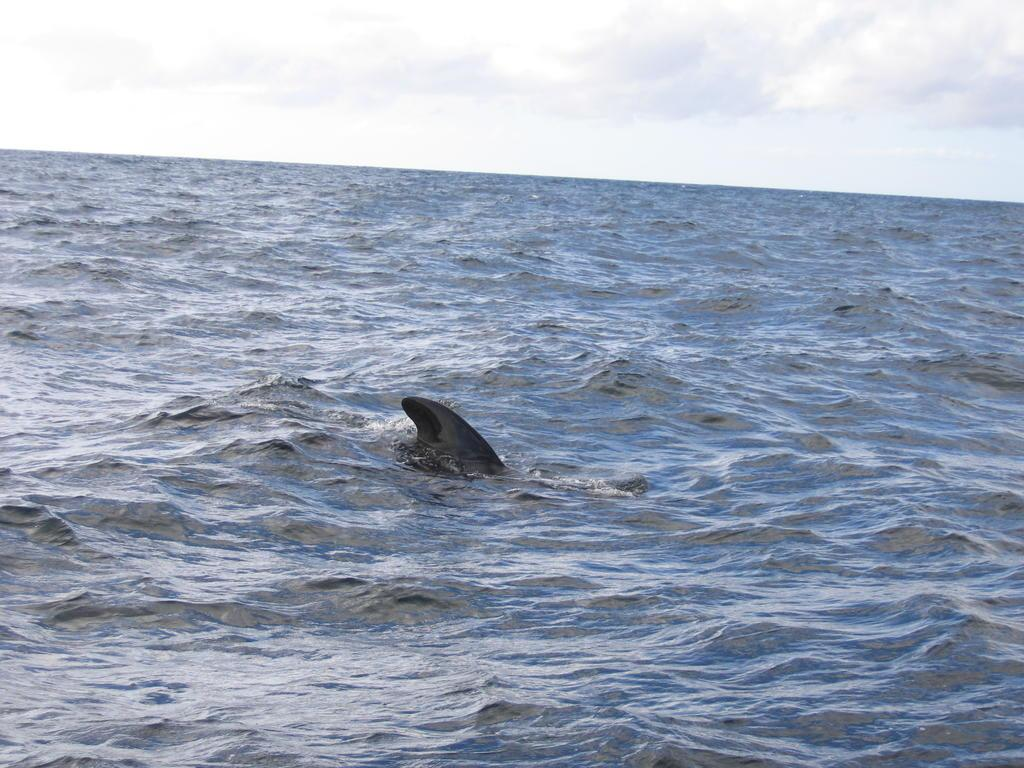What is the primary element present in the image? There is water in the image. What can be seen submerged in the water? There is a black-colored object in the water. What is visible in the background of the image? The sky is visible in the background of the image. How would you describe the sky in the image? The sky appears to be cloudy. What type of cabbage is growing in the water in the image? There is no cabbage present in the image; it features water with a black-colored object submerged. How many rings can be seen on the black-colored object in the image? There are no rings visible on the black-colored object in the image. 